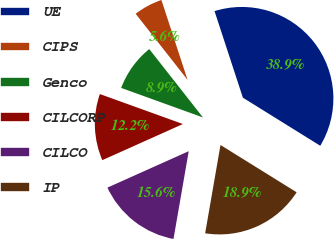Convert chart to OTSL. <chart><loc_0><loc_0><loc_500><loc_500><pie_chart><fcel>UE<fcel>CIPS<fcel>Genco<fcel>CILCORP<fcel>CILCO<fcel>IP<nl><fcel>38.89%<fcel>5.56%<fcel>8.89%<fcel>12.22%<fcel>15.56%<fcel>18.89%<nl></chart> 